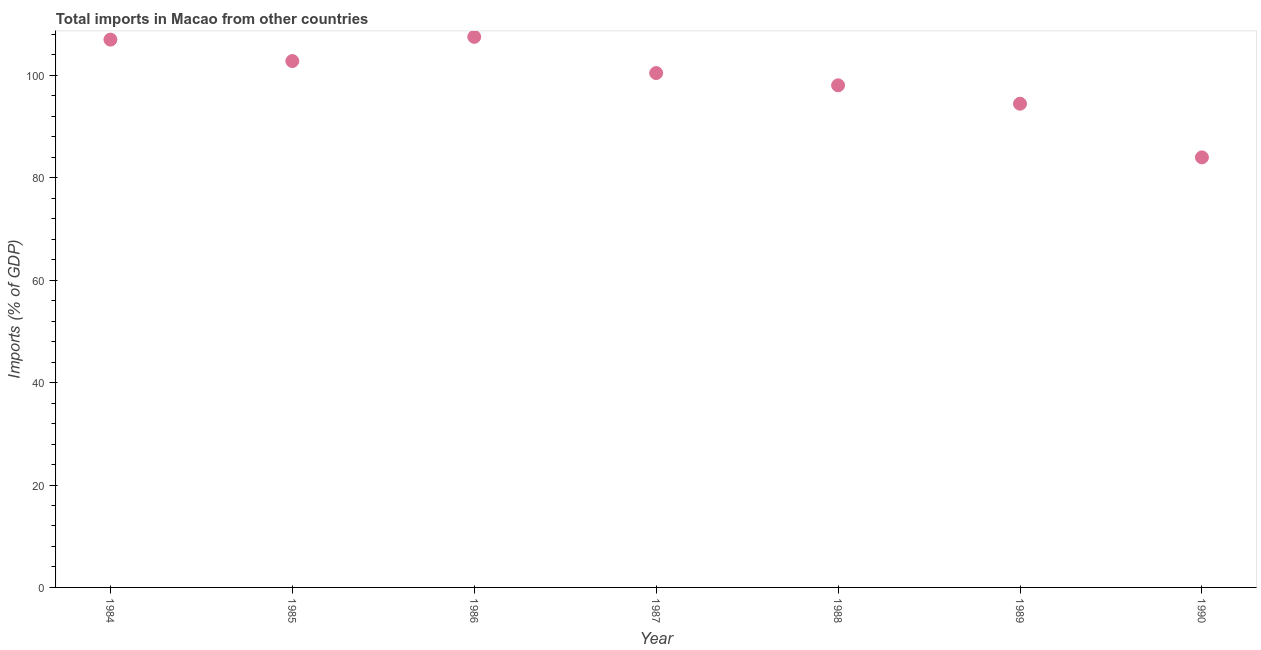What is the total imports in 1985?
Make the answer very short. 102.78. Across all years, what is the maximum total imports?
Make the answer very short. 107.51. Across all years, what is the minimum total imports?
Provide a succinct answer. 83.97. What is the sum of the total imports?
Offer a very short reply. 694.15. What is the difference between the total imports in 1984 and 1985?
Offer a very short reply. 4.19. What is the average total imports per year?
Make the answer very short. 99.16. What is the median total imports?
Provide a short and direct response. 100.44. In how many years, is the total imports greater than 24 %?
Your answer should be very brief. 7. What is the ratio of the total imports in 1985 to that in 1990?
Your response must be concise. 1.22. Is the total imports in 1987 less than that in 1988?
Provide a succinct answer. No. What is the difference between the highest and the second highest total imports?
Make the answer very short. 0.54. What is the difference between the highest and the lowest total imports?
Provide a succinct answer. 23.54. Does the total imports monotonically increase over the years?
Provide a succinct answer. No. How many dotlines are there?
Your response must be concise. 1. Does the graph contain any zero values?
Offer a terse response. No. Does the graph contain grids?
Your answer should be very brief. No. What is the title of the graph?
Provide a short and direct response. Total imports in Macao from other countries. What is the label or title of the X-axis?
Make the answer very short. Year. What is the label or title of the Y-axis?
Keep it short and to the point. Imports (% of GDP). What is the Imports (% of GDP) in 1984?
Provide a succinct answer. 106.97. What is the Imports (% of GDP) in 1985?
Make the answer very short. 102.78. What is the Imports (% of GDP) in 1986?
Provide a short and direct response. 107.51. What is the Imports (% of GDP) in 1987?
Provide a succinct answer. 100.44. What is the Imports (% of GDP) in 1988?
Keep it short and to the point. 98.04. What is the Imports (% of GDP) in 1989?
Your answer should be compact. 94.45. What is the Imports (% of GDP) in 1990?
Provide a succinct answer. 83.97. What is the difference between the Imports (% of GDP) in 1984 and 1985?
Offer a terse response. 4.19. What is the difference between the Imports (% of GDP) in 1984 and 1986?
Provide a succinct answer. -0.54. What is the difference between the Imports (% of GDP) in 1984 and 1987?
Ensure brevity in your answer.  6.53. What is the difference between the Imports (% of GDP) in 1984 and 1988?
Make the answer very short. 8.92. What is the difference between the Imports (% of GDP) in 1984 and 1989?
Make the answer very short. 12.52. What is the difference between the Imports (% of GDP) in 1984 and 1990?
Give a very brief answer. 22.99. What is the difference between the Imports (% of GDP) in 1985 and 1986?
Provide a short and direct response. -4.73. What is the difference between the Imports (% of GDP) in 1985 and 1987?
Ensure brevity in your answer.  2.34. What is the difference between the Imports (% of GDP) in 1985 and 1988?
Your answer should be compact. 4.74. What is the difference between the Imports (% of GDP) in 1985 and 1989?
Offer a very short reply. 8.33. What is the difference between the Imports (% of GDP) in 1985 and 1990?
Offer a terse response. 18.81. What is the difference between the Imports (% of GDP) in 1986 and 1987?
Provide a short and direct response. 7.07. What is the difference between the Imports (% of GDP) in 1986 and 1988?
Your response must be concise. 9.46. What is the difference between the Imports (% of GDP) in 1986 and 1989?
Offer a very short reply. 13.06. What is the difference between the Imports (% of GDP) in 1986 and 1990?
Provide a succinct answer. 23.54. What is the difference between the Imports (% of GDP) in 1987 and 1988?
Your answer should be compact. 2.4. What is the difference between the Imports (% of GDP) in 1987 and 1989?
Ensure brevity in your answer.  5.99. What is the difference between the Imports (% of GDP) in 1987 and 1990?
Give a very brief answer. 16.47. What is the difference between the Imports (% of GDP) in 1988 and 1989?
Provide a short and direct response. 3.59. What is the difference between the Imports (% of GDP) in 1988 and 1990?
Offer a very short reply. 14.07. What is the difference between the Imports (% of GDP) in 1989 and 1990?
Provide a succinct answer. 10.48. What is the ratio of the Imports (% of GDP) in 1984 to that in 1985?
Your answer should be very brief. 1.04. What is the ratio of the Imports (% of GDP) in 1984 to that in 1987?
Your answer should be very brief. 1.06. What is the ratio of the Imports (% of GDP) in 1984 to that in 1988?
Your response must be concise. 1.09. What is the ratio of the Imports (% of GDP) in 1984 to that in 1989?
Offer a terse response. 1.13. What is the ratio of the Imports (% of GDP) in 1984 to that in 1990?
Make the answer very short. 1.27. What is the ratio of the Imports (% of GDP) in 1985 to that in 1986?
Your answer should be very brief. 0.96. What is the ratio of the Imports (% of GDP) in 1985 to that in 1988?
Keep it short and to the point. 1.05. What is the ratio of the Imports (% of GDP) in 1985 to that in 1989?
Your answer should be very brief. 1.09. What is the ratio of the Imports (% of GDP) in 1985 to that in 1990?
Your answer should be compact. 1.22. What is the ratio of the Imports (% of GDP) in 1986 to that in 1987?
Your response must be concise. 1.07. What is the ratio of the Imports (% of GDP) in 1986 to that in 1988?
Your response must be concise. 1.1. What is the ratio of the Imports (% of GDP) in 1986 to that in 1989?
Your response must be concise. 1.14. What is the ratio of the Imports (% of GDP) in 1986 to that in 1990?
Your answer should be very brief. 1.28. What is the ratio of the Imports (% of GDP) in 1987 to that in 1989?
Give a very brief answer. 1.06. What is the ratio of the Imports (% of GDP) in 1987 to that in 1990?
Make the answer very short. 1.2. What is the ratio of the Imports (% of GDP) in 1988 to that in 1989?
Ensure brevity in your answer.  1.04. What is the ratio of the Imports (% of GDP) in 1988 to that in 1990?
Ensure brevity in your answer.  1.17. 